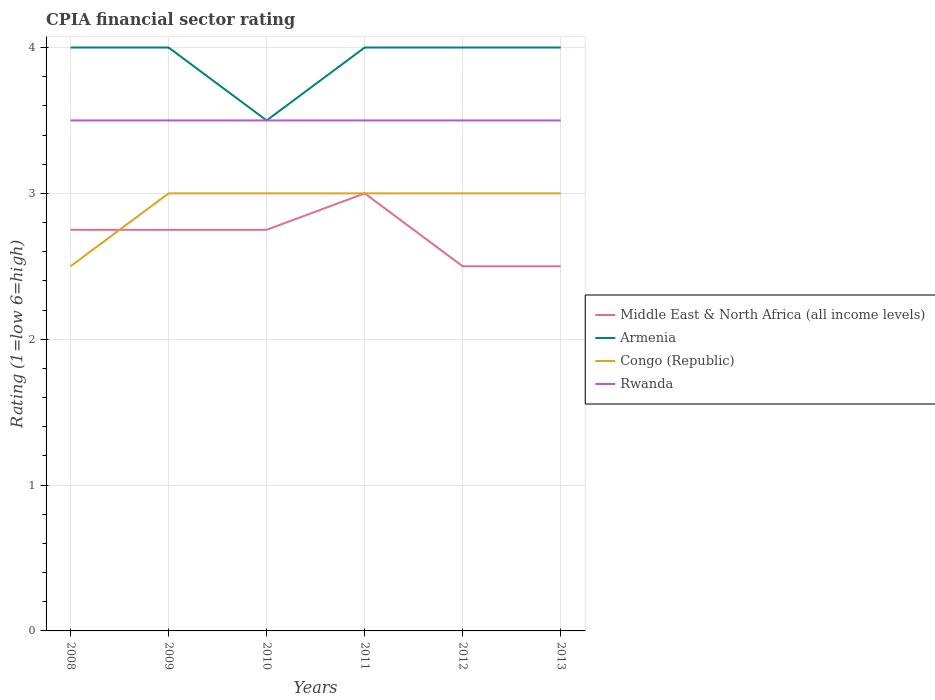How many different coloured lines are there?
Keep it short and to the point. 4. Across all years, what is the maximum CPIA rating in Congo (Republic)?
Make the answer very short. 2.5. In which year was the CPIA rating in Rwanda maximum?
Offer a terse response. 2008. What is the difference between the highest and the lowest CPIA rating in Armenia?
Keep it short and to the point. 5. Is the CPIA rating in Rwanda strictly greater than the CPIA rating in Middle East & North Africa (all income levels) over the years?
Your answer should be very brief. No. How many years are there in the graph?
Your response must be concise. 6. What is the difference between two consecutive major ticks on the Y-axis?
Provide a succinct answer. 1. Are the values on the major ticks of Y-axis written in scientific E-notation?
Make the answer very short. No. How are the legend labels stacked?
Keep it short and to the point. Vertical. What is the title of the graph?
Your answer should be compact. CPIA financial sector rating. What is the label or title of the X-axis?
Make the answer very short. Years. What is the label or title of the Y-axis?
Give a very brief answer. Rating (1=low 6=high). What is the Rating (1=low 6=high) in Middle East & North Africa (all income levels) in 2008?
Ensure brevity in your answer.  2.75. What is the Rating (1=low 6=high) in Congo (Republic) in 2008?
Your answer should be compact. 2.5. What is the Rating (1=low 6=high) in Rwanda in 2008?
Provide a succinct answer. 3.5. What is the Rating (1=low 6=high) of Middle East & North Africa (all income levels) in 2009?
Give a very brief answer. 2.75. What is the Rating (1=low 6=high) of Congo (Republic) in 2009?
Your response must be concise. 3. What is the Rating (1=low 6=high) of Middle East & North Africa (all income levels) in 2010?
Keep it short and to the point. 2.75. What is the Rating (1=low 6=high) in Rwanda in 2010?
Offer a terse response. 3.5. What is the Rating (1=low 6=high) of Armenia in 2011?
Provide a short and direct response. 4. What is the Rating (1=low 6=high) in Rwanda in 2011?
Ensure brevity in your answer.  3.5. What is the Rating (1=low 6=high) of Middle East & North Africa (all income levels) in 2012?
Provide a short and direct response. 2.5. What is the Rating (1=low 6=high) of Armenia in 2012?
Offer a terse response. 4. What is the Rating (1=low 6=high) of Congo (Republic) in 2012?
Your answer should be compact. 3. What is the Rating (1=low 6=high) of Rwanda in 2012?
Provide a succinct answer. 3.5. What is the Rating (1=low 6=high) of Middle East & North Africa (all income levels) in 2013?
Your response must be concise. 2.5. What is the Rating (1=low 6=high) in Rwanda in 2013?
Provide a short and direct response. 3.5. Across all years, what is the maximum Rating (1=low 6=high) of Middle East & North Africa (all income levels)?
Offer a terse response. 3. Across all years, what is the minimum Rating (1=low 6=high) of Congo (Republic)?
Your response must be concise. 2.5. What is the total Rating (1=low 6=high) in Middle East & North Africa (all income levels) in the graph?
Your answer should be compact. 16.25. What is the total Rating (1=low 6=high) of Congo (Republic) in the graph?
Give a very brief answer. 17.5. What is the total Rating (1=low 6=high) in Rwanda in the graph?
Provide a succinct answer. 21. What is the difference between the Rating (1=low 6=high) in Middle East & North Africa (all income levels) in 2008 and that in 2009?
Make the answer very short. 0. What is the difference between the Rating (1=low 6=high) in Armenia in 2008 and that in 2009?
Your answer should be very brief. 0. What is the difference between the Rating (1=low 6=high) of Congo (Republic) in 2008 and that in 2009?
Give a very brief answer. -0.5. What is the difference between the Rating (1=low 6=high) in Rwanda in 2008 and that in 2009?
Offer a terse response. 0. What is the difference between the Rating (1=low 6=high) of Armenia in 2008 and that in 2010?
Keep it short and to the point. 0.5. What is the difference between the Rating (1=low 6=high) of Congo (Republic) in 2008 and that in 2010?
Offer a terse response. -0.5. What is the difference between the Rating (1=low 6=high) in Rwanda in 2008 and that in 2010?
Offer a terse response. 0. What is the difference between the Rating (1=low 6=high) of Middle East & North Africa (all income levels) in 2008 and that in 2011?
Provide a short and direct response. -0.25. What is the difference between the Rating (1=low 6=high) of Armenia in 2008 and that in 2011?
Your answer should be very brief. 0. What is the difference between the Rating (1=low 6=high) of Congo (Republic) in 2008 and that in 2011?
Make the answer very short. -0.5. What is the difference between the Rating (1=low 6=high) in Rwanda in 2008 and that in 2011?
Provide a succinct answer. 0. What is the difference between the Rating (1=low 6=high) of Middle East & North Africa (all income levels) in 2008 and that in 2012?
Your response must be concise. 0.25. What is the difference between the Rating (1=low 6=high) of Congo (Republic) in 2008 and that in 2012?
Make the answer very short. -0.5. What is the difference between the Rating (1=low 6=high) in Rwanda in 2008 and that in 2012?
Offer a terse response. 0. What is the difference between the Rating (1=low 6=high) of Armenia in 2008 and that in 2013?
Offer a very short reply. 0. What is the difference between the Rating (1=low 6=high) in Congo (Republic) in 2008 and that in 2013?
Provide a short and direct response. -0.5. What is the difference between the Rating (1=low 6=high) of Rwanda in 2008 and that in 2013?
Offer a very short reply. 0. What is the difference between the Rating (1=low 6=high) in Armenia in 2009 and that in 2010?
Provide a succinct answer. 0.5. What is the difference between the Rating (1=low 6=high) of Rwanda in 2009 and that in 2010?
Ensure brevity in your answer.  0. What is the difference between the Rating (1=low 6=high) in Armenia in 2009 and that in 2011?
Ensure brevity in your answer.  0. What is the difference between the Rating (1=low 6=high) of Congo (Republic) in 2009 and that in 2011?
Provide a succinct answer. 0. What is the difference between the Rating (1=low 6=high) in Armenia in 2009 and that in 2012?
Offer a very short reply. 0. What is the difference between the Rating (1=low 6=high) of Rwanda in 2009 and that in 2012?
Offer a terse response. 0. What is the difference between the Rating (1=low 6=high) in Middle East & North Africa (all income levels) in 2009 and that in 2013?
Offer a very short reply. 0.25. What is the difference between the Rating (1=low 6=high) of Armenia in 2009 and that in 2013?
Your answer should be very brief. 0. What is the difference between the Rating (1=low 6=high) of Rwanda in 2009 and that in 2013?
Your response must be concise. 0. What is the difference between the Rating (1=low 6=high) in Middle East & North Africa (all income levels) in 2010 and that in 2011?
Make the answer very short. -0.25. What is the difference between the Rating (1=low 6=high) in Armenia in 2010 and that in 2011?
Your response must be concise. -0.5. What is the difference between the Rating (1=low 6=high) in Middle East & North Africa (all income levels) in 2010 and that in 2012?
Your answer should be very brief. 0.25. What is the difference between the Rating (1=low 6=high) of Armenia in 2010 and that in 2012?
Offer a terse response. -0.5. What is the difference between the Rating (1=low 6=high) in Congo (Republic) in 2010 and that in 2012?
Make the answer very short. 0. What is the difference between the Rating (1=low 6=high) of Middle East & North Africa (all income levels) in 2010 and that in 2013?
Make the answer very short. 0.25. What is the difference between the Rating (1=low 6=high) in Armenia in 2010 and that in 2013?
Offer a very short reply. -0.5. What is the difference between the Rating (1=low 6=high) in Congo (Republic) in 2010 and that in 2013?
Provide a short and direct response. 0. What is the difference between the Rating (1=low 6=high) in Rwanda in 2011 and that in 2012?
Your answer should be compact. 0. What is the difference between the Rating (1=low 6=high) in Middle East & North Africa (all income levels) in 2011 and that in 2013?
Give a very brief answer. 0.5. What is the difference between the Rating (1=low 6=high) in Armenia in 2011 and that in 2013?
Make the answer very short. 0. What is the difference between the Rating (1=low 6=high) of Congo (Republic) in 2011 and that in 2013?
Give a very brief answer. 0. What is the difference between the Rating (1=low 6=high) in Armenia in 2012 and that in 2013?
Your answer should be compact. 0. What is the difference between the Rating (1=low 6=high) of Middle East & North Africa (all income levels) in 2008 and the Rating (1=low 6=high) of Armenia in 2009?
Give a very brief answer. -1.25. What is the difference between the Rating (1=low 6=high) in Middle East & North Africa (all income levels) in 2008 and the Rating (1=low 6=high) in Rwanda in 2009?
Provide a short and direct response. -0.75. What is the difference between the Rating (1=low 6=high) of Congo (Republic) in 2008 and the Rating (1=low 6=high) of Rwanda in 2009?
Ensure brevity in your answer.  -1. What is the difference between the Rating (1=low 6=high) of Middle East & North Africa (all income levels) in 2008 and the Rating (1=low 6=high) of Armenia in 2010?
Provide a short and direct response. -0.75. What is the difference between the Rating (1=low 6=high) of Middle East & North Africa (all income levels) in 2008 and the Rating (1=low 6=high) of Rwanda in 2010?
Offer a very short reply. -0.75. What is the difference between the Rating (1=low 6=high) of Congo (Republic) in 2008 and the Rating (1=low 6=high) of Rwanda in 2010?
Your answer should be compact. -1. What is the difference between the Rating (1=low 6=high) of Middle East & North Africa (all income levels) in 2008 and the Rating (1=low 6=high) of Armenia in 2011?
Provide a succinct answer. -1.25. What is the difference between the Rating (1=low 6=high) of Middle East & North Africa (all income levels) in 2008 and the Rating (1=low 6=high) of Congo (Republic) in 2011?
Provide a succinct answer. -0.25. What is the difference between the Rating (1=low 6=high) in Middle East & North Africa (all income levels) in 2008 and the Rating (1=low 6=high) in Rwanda in 2011?
Offer a terse response. -0.75. What is the difference between the Rating (1=low 6=high) in Armenia in 2008 and the Rating (1=low 6=high) in Congo (Republic) in 2011?
Offer a terse response. 1. What is the difference between the Rating (1=low 6=high) in Middle East & North Africa (all income levels) in 2008 and the Rating (1=low 6=high) in Armenia in 2012?
Keep it short and to the point. -1.25. What is the difference between the Rating (1=low 6=high) of Middle East & North Africa (all income levels) in 2008 and the Rating (1=low 6=high) of Rwanda in 2012?
Provide a succinct answer. -0.75. What is the difference between the Rating (1=low 6=high) of Middle East & North Africa (all income levels) in 2008 and the Rating (1=low 6=high) of Armenia in 2013?
Offer a very short reply. -1.25. What is the difference between the Rating (1=low 6=high) in Middle East & North Africa (all income levels) in 2008 and the Rating (1=low 6=high) in Rwanda in 2013?
Offer a terse response. -0.75. What is the difference between the Rating (1=low 6=high) of Armenia in 2008 and the Rating (1=low 6=high) of Rwanda in 2013?
Keep it short and to the point. 0.5. What is the difference between the Rating (1=low 6=high) of Congo (Republic) in 2008 and the Rating (1=low 6=high) of Rwanda in 2013?
Offer a very short reply. -1. What is the difference between the Rating (1=low 6=high) of Middle East & North Africa (all income levels) in 2009 and the Rating (1=low 6=high) of Armenia in 2010?
Your answer should be compact. -0.75. What is the difference between the Rating (1=low 6=high) of Middle East & North Africa (all income levels) in 2009 and the Rating (1=low 6=high) of Rwanda in 2010?
Keep it short and to the point. -0.75. What is the difference between the Rating (1=low 6=high) of Armenia in 2009 and the Rating (1=low 6=high) of Congo (Republic) in 2010?
Offer a very short reply. 1. What is the difference between the Rating (1=low 6=high) of Armenia in 2009 and the Rating (1=low 6=high) of Rwanda in 2010?
Ensure brevity in your answer.  0.5. What is the difference between the Rating (1=low 6=high) of Middle East & North Africa (all income levels) in 2009 and the Rating (1=low 6=high) of Armenia in 2011?
Your answer should be very brief. -1.25. What is the difference between the Rating (1=low 6=high) of Middle East & North Africa (all income levels) in 2009 and the Rating (1=low 6=high) of Rwanda in 2011?
Provide a short and direct response. -0.75. What is the difference between the Rating (1=low 6=high) in Armenia in 2009 and the Rating (1=low 6=high) in Congo (Republic) in 2011?
Offer a very short reply. 1. What is the difference between the Rating (1=low 6=high) of Armenia in 2009 and the Rating (1=low 6=high) of Rwanda in 2011?
Provide a succinct answer. 0.5. What is the difference between the Rating (1=low 6=high) of Middle East & North Africa (all income levels) in 2009 and the Rating (1=low 6=high) of Armenia in 2012?
Make the answer very short. -1.25. What is the difference between the Rating (1=low 6=high) in Middle East & North Africa (all income levels) in 2009 and the Rating (1=low 6=high) in Congo (Republic) in 2012?
Your answer should be compact. -0.25. What is the difference between the Rating (1=low 6=high) in Middle East & North Africa (all income levels) in 2009 and the Rating (1=low 6=high) in Rwanda in 2012?
Offer a terse response. -0.75. What is the difference between the Rating (1=low 6=high) of Congo (Republic) in 2009 and the Rating (1=low 6=high) of Rwanda in 2012?
Make the answer very short. -0.5. What is the difference between the Rating (1=low 6=high) in Middle East & North Africa (all income levels) in 2009 and the Rating (1=low 6=high) in Armenia in 2013?
Offer a very short reply. -1.25. What is the difference between the Rating (1=low 6=high) of Middle East & North Africa (all income levels) in 2009 and the Rating (1=low 6=high) of Rwanda in 2013?
Your answer should be very brief. -0.75. What is the difference between the Rating (1=low 6=high) in Congo (Republic) in 2009 and the Rating (1=low 6=high) in Rwanda in 2013?
Offer a terse response. -0.5. What is the difference between the Rating (1=low 6=high) of Middle East & North Africa (all income levels) in 2010 and the Rating (1=low 6=high) of Armenia in 2011?
Make the answer very short. -1.25. What is the difference between the Rating (1=low 6=high) of Middle East & North Africa (all income levels) in 2010 and the Rating (1=low 6=high) of Rwanda in 2011?
Your answer should be compact. -0.75. What is the difference between the Rating (1=low 6=high) in Armenia in 2010 and the Rating (1=low 6=high) in Congo (Republic) in 2011?
Offer a very short reply. 0.5. What is the difference between the Rating (1=low 6=high) in Armenia in 2010 and the Rating (1=low 6=high) in Rwanda in 2011?
Make the answer very short. 0. What is the difference between the Rating (1=low 6=high) of Congo (Republic) in 2010 and the Rating (1=low 6=high) of Rwanda in 2011?
Make the answer very short. -0.5. What is the difference between the Rating (1=low 6=high) in Middle East & North Africa (all income levels) in 2010 and the Rating (1=low 6=high) in Armenia in 2012?
Offer a terse response. -1.25. What is the difference between the Rating (1=low 6=high) in Middle East & North Africa (all income levels) in 2010 and the Rating (1=low 6=high) in Rwanda in 2012?
Make the answer very short. -0.75. What is the difference between the Rating (1=low 6=high) in Armenia in 2010 and the Rating (1=low 6=high) in Rwanda in 2012?
Keep it short and to the point. 0. What is the difference between the Rating (1=low 6=high) in Middle East & North Africa (all income levels) in 2010 and the Rating (1=low 6=high) in Armenia in 2013?
Offer a very short reply. -1.25. What is the difference between the Rating (1=low 6=high) of Middle East & North Africa (all income levels) in 2010 and the Rating (1=low 6=high) of Rwanda in 2013?
Provide a succinct answer. -0.75. What is the difference between the Rating (1=low 6=high) in Armenia in 2010 and the Rating (1=low 6=high) in Congo (Republic) in 2013?
Offer a very short reply. 0.5. What is the difference between the Rating (1=low 6=high) of Armenia in 2010 and the Rating (1=low 6=high) of Rwanda in 2013?
Offer a terse response. 0. What is the difference between the Rating (1=low 6=high) in Congo (Republic) in 2010 and the Rating (1=low 6=high) in Rwanda in 2013?
Provide a succinct answer. -0.5. What is the difference between the Rating (1=low 6=high) in Middle East & North Africa (all income levels) in 2011 and the Rating (1=low 6=high) in Rwanda in 2012?
Ensure brevity in your answer.  -0.5. What is the difference between the Rating (1=low 6=high) of Armenia in 2011 and the Rating (1=low 6=high) of Congo (Republic) in 2012?
Offer a terse response. 1. What is the difference between the Rating (1=low 6=high) in Armenia in 2011 and the Rating (1=low 6=high) in Rwanda in 2012?
Give a very brief answer. 0.5. What is the difference between the Rating (1=low 6=high) of Middle East & North Africa (all income levels) in 2011 and the Rating (1=low 6=high) of Armenia in 2013?
Offer a very short reply. -1. What is the difference between the Rating (1=low 6=high) in Middle East & North Africa (all income levels) in 2011 and the Rating (1=low 6=high) in Congo (Republic) in 2013?
Provide a succinct answer. 0. What is the difference between the Rating (1=low 6=high) of Armenia in 2011 and the Rating (1=low 6=high) of Congo (Republic) in 2013?
Ensure brevity in your answer.  1. What is the difference between the Rating (1=low 6=high) in Middle East & North Africa (all income levels) in 2012 and the Rating (1=low 6=high) in Armenia in 2013?
Your response must be concise. -1.5. What is the difference between the Rating (1=low 6=high) in Middle East & North Africa (all income levels) in 2012 and the Rating (1=low 6=high) in Congo (Republic) in 2013?
Your answer should be very brief. -0.5. What is the difference between the Rating (1=low 6=high) of Middle East & North Africa (all income levels) in 2012 and the Rating (1=low 6=high) of Rwanda in 2013?
Give a very brief answer. -1. What is the average Rating (1=low 6=high) in Middle East & North Africa (all income levels) per year?
Offer a terse response. 2.71. What is the average Rating (1=low 6=high) in Armenia per year?
Your answer should be very brief. 3.92. What is the average Rating (1=low 6=high) of Congo (Republic) per year?
Offer a very short reply. 2.92. In the year 2008, what is the difference between the Rating (1=low 6=high) in Middle East & North Africa (all income levels) and Rating (1=low 6=high) in Armenia?
Provide a succinct answer. -1.25. In the year 2008, what is the difference between the Rating (1=low 6=high) in Middle East & North Africa (all income levels) and Rating (1=low 6=high) in Congo (Republic)?
Offer a very short reply. 0.25. In the year 2008, what is the difference between the Rating (1=low 6=high) of Middle East & North Africa (all income levels) and Rating (1=low 6=high) of Rwanda?
Keep it short and to the point. -0.75. In the year 2008, what is the difference between the Rating (1=low 6=high) in Armenia and Rating (1=low 6=high) in Congo (Republic)?
Your answer should be very brief. 1.5. In the year 2008, what is the difference between the Rating (1=low 6=high) in Armenia and Rating (1=low 6=high) in Rwanda?
Offer a very short reply. 0.5. In the year 2008, what is the difference between the Rating (1=low 6=high) of Congo (Republic) and Rating (1=low 6=high) of Rwanda?
Make the answer very short. -1. In the year 2009, what is the difference between the Rating (1=low 6=high) in Middle East & North Africa (all income levels) and Rating (1=low 6=high) in Armenia?
Your answer should be very brief. -1.25. In the year 2009, what is the difference between the Rating (1=low 6=high) in Middle East & North Africa (all income levels) and Rating (1=low 6=high) in Congo (Republic)?
Make the answer very short. -0.25. In the year 2009, what is the difference between the Rating (1=low 6=high) in Middle East & North Africa (all income levels) and Rating (1=low 6=high) in Rwanda?
Your answer should be compact. -0.75. In the year 2009, what is the difference between the Rating (1=low 6=high) of Armenia and Rating (1=low 6=high) of Rwanda?
Ensure brevity in your answer.  0.5. In the year 2010, what is the difference between the Rating (1=low 6=high) of Middle East & North Africa (all income levels) and Rating (1=low 6=high) of Armenia?
Your answer should be compact. -0.75. In the year 2010, what is the difference between the Rating (1=low 6=high) of Middle East & North Africa (all income levels) and Rating (1=low 6=high) of Congo (Republic)?
Provide a short and direct response. -0.25. In the year 2010, what is the difference between the Rating (1=low 6=high) of Middle East & North Africa (all income levels) and Rating (1=low 6=high) of Rwanda?
Provide a succinct answer. -0.75. In the year 2010, what is the difference between the Rating (1=low 6=high) in Armenia and Rating (1=low 6=high) in Congo (Republic)?
Keep it short and to the point. 0.5. In the year 2010, what is the difference between the Rating (1=low 6=high) in Congo (Republic) and Rating (1=low 6=high) in Rwanda?
Ensure brevity in your answer.  -0.5. In the year 2011, what is the difference between the Rating (1=low 6=high) of Middle East & North Africa (all income levels) and Rating (1=low 6=high) of Armenia?
Give a very brief answer. -1. In the year 2011, what is the difference between the Rating (1=low 6=high) of Middle East & North Africa (all income levels) and Rating (1=low 6=high) of Rwanda?
Provide a succinct answer. -0.5. In the year 2011, what is the difference between the Rating (1=low 6=high) in Armenia and Rating (1=low 6=high) in Congo (Republic)?
Offer a terse response. 1. In the year 2011, what is the difference between the Rating (1=low 6=high) in Congo (Republic) and Rating (1=low 6=high) in Rwanda?
Your response must be concise. -0.5. In the year 2012, what is the difference between the Rating (1=low 6=high) in Middle East & North Africa (all income levels) and Rating (1=low 6=high) in Armenia?
Ensure brevity in your answer.  -1.5. In the year 2012, what is the difference between the Rating (1=low 6=high) in Middle East & North Africa (all income levels) and Rating (1=low 6=high) in Rwanda?
Make the answer very short. -1. In the year 2012, what is the difference between the Rating (1=low 6=high) in Armenia and Rating (1=low 6=high) in Rwanda?
Give a very brief answer. 0.5. In the year 2013, what is the difference between the Rating (1=low 6=high) of Middle East & North Africa (all income levels) and Rating (1=low 6=high) of Armenia?
Offer a terse response. -1.5. In the year 2013, what is the difference between the Rating (1=low 6=high) in Middle East & North Africa (all income levels) and Rating (1=low 6=high) in Congo (Republic)?
Keep it short and to the point. -0.5. In the year 2013, what is the difference between the Rating (1=low 6=high) of Armenia and Rating (1=low 6=high) of Congo (Republic)?
Offer a terse response. 1. In the year 2013, what is the difference between the Rating (1=low 6=high) in Armenia and Rating (1=low 6=high) in Rwanda?
Your answer should be very brief. 0.5. In the year 2013, what is the difference between the Rating (1=low 6=high) of Congo (Republic) and Rating (1=low 6=high) of Rwanda?
Keep it short and to the point. -0.5. What is the ratio of the Rating (1=low 6=high) of Middle East & North Africa (all income levels) in 2008 to that in 2009?
Offer a terse response. 1. What is the ratio of the Rating (1=low 6=high) in Armenia in 2008 to that in 2009?
Ensure brevity in your answer.  1. What is the ratio of the Rating (1=low 6=high) of Congo (Republic) in 2008 to that in 2009?
Your response must be concise. 0.83. What is the ratio of the Rating (1=low 6=high) in Armenia in 2008 to that in 2010?
Make the answer very short. 1.14. What is the ratio of the Rating (1=low 6=high) of Congo (Republic) in 2008 to that in 2010?
Your answer should be compact. 0.83. What is the ratio of the Rating (1=low 6=high) in Rwanda in 2008 to that in 2010?
Provide a succinct answer. 1. What is the ratio of the Rating (1=low 6=high) of Middle East & North Africa (all income levels) in 2008 to that in 2011?
Your answer should be compact. 0.92. What is the ratio of the Rating (1=low 6=high) of Armenia in 2008 to that in 2011?
Provide a succinct answer. 1. What is the ratio of the Rating (1=low 6=high) in Rwanda in 2008 to that in 2011?
Ensure brevity in your answer.  1. What is the ratio of the Rating (1=low 6=high) in Middle East & North Africa (all income levels) in 2008 to that in 2012?
Make the answer very short. 1.1. What is the ratio of the Rating (1=low 6=high) in Congo (Republic) in 2008 to that in 2012?
Provide a short and direct response. 0.83. What is the ratio of the Rating (1=low 6=high) in Congo (Republic) in 2008 to that in 2013?
Keep it short and to the point. 0.83. What is the ratio of the Rating (1=low 6=high) of Armenia in 2009 to that in 2010?
Keep it short and to the point. 1.14. What is the ratio of the Rating (1=low 6=high) in Congo (Republic) in 2009 to that in 2010?
Offer a terse response. 1. What is the ratio of the Rating (1=low 6=high) in Middle East & North Africa (all income levels) in 2009 to that in 2011?
Make the answer very short. 0.92. What is the ratio of the Rating (1=low 6=high) of Armenia in 2009 to that in 2011?
Your answer should be very brief. 1. What is the ratio of the Rating (1=low 6=high) in Middle East & North Africa (all income levels) in 2009 to that in 2012?
Your answer should be compact. 1.1. What is the ratio of the Rating (1=low 6=high) in Armenia in 2009 to that in 2012?
Keep it short and to the point. 1. What is the ratio of the Rating (1=low 6=high) in Congo (Republic) in 2009 to that in 2012?
Your answer should be compact. 1. What is the ratio of the Rating (1=low 6=high) in Rwanda in 2009 to that in 2012?
Provide a short and direct response. 1. What is the ratio of the Rating (1=low 6=high) of Armenia in 2009 to that in 2013?
Ensure brevity in your answer.  1. What is the ratio of the Rating (1=low 6=high) of Congo (Republic) in 2009 to that in 2013?
Offer a very short reply. 1. What is the ratio of the Rating (1=low 6=high) of Rwanda in 2009 to that in 2013?
Make the answer very short. 1. What is the ratio of the Rating (1=low 6=high) in Armenia in 2010 to that in 2011?
Your answer should be compact. 0.88. What is the ratio of the Rating (1=low 6=high) of Congo (Republic) in 2010 to that in 2011?
Offer a terse response. 1. What is the ratio of the Rating (1=low 6=high) in Rwanda in 2010 to that in 2011?
Provide a short and direct response. 1. What is the ratio of the Rating (1=low 6=high) in Middle East & North Africa (all income levels) in 2010 to that in 2012?
Your answer should be compact. 1.1. What is the ratio of the Rating (1=low 6=high) in Armenia in 2010 to that in 2012?
Keep it short and to the point. 0.88. What is the ratio of the Rating (1=low 6=high) in Congo (Republic) in 2010 to that in 2012?
Make the answer very short. 1. What is the ratio of the Rating (1=low 6=high) in Rwanda in 2010 to that in 2012?
Your answer should be compact. 1. What is the ratio of the Rating (1=low 6=high) of Middle East & North Africa (all income levels) in 2010 to that in 2013?
Your answer should be compact. 1.1. What is the ratio of the Rating (1=low 6=high) in Armenia in 2010 to that in 2013?
Offer a terse response. 0.88. What is the ratio of the Rating (1=low 6=high) of Congo (Republic) in 2010 to that in 2013?
Make the answer very short. 1. What is the ratio of the Rating (1=low 6=high) of Congo (Republic) in 2011 to that in 2012?
Provide a succinct answer. 1. What is the ratio of the Rating (1=low 6=high) in Rwanda in 2011 to that in 2012?
Make the answer very short. 1. What is the ratio of the Rating (1=low 6=high) of Middle East & North Africa (all income levels) in 2011 to that in 2013?
Offer a terse response. 1.2. What is the ratio of the Rating (1=low 6=high) in Congo (Republic) in 2011 to that in 2013?
Give a very brief answer. 1. What is the ratio of the Rating (1=low 6=high) in Rwanda in 2011 to that in 2013?
Provide a succinct answer. 1. What is the ratio of the Rating (1=low 6=high) of Congo (Republic) in 2012 to that in 2013?
Ensure brevity in your answer.  1. What is the difference between the highest and the lowest Rating (1=low 6=high) of Armenia?
Provide a succinct answer. 0.5. 